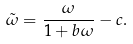Convert formula to latex. <formula><loc_0><loc_0><loc_500><loc_500>\tilde { \omega } = \frac { \omega } { 1 + b \omega } - c .</formula> 